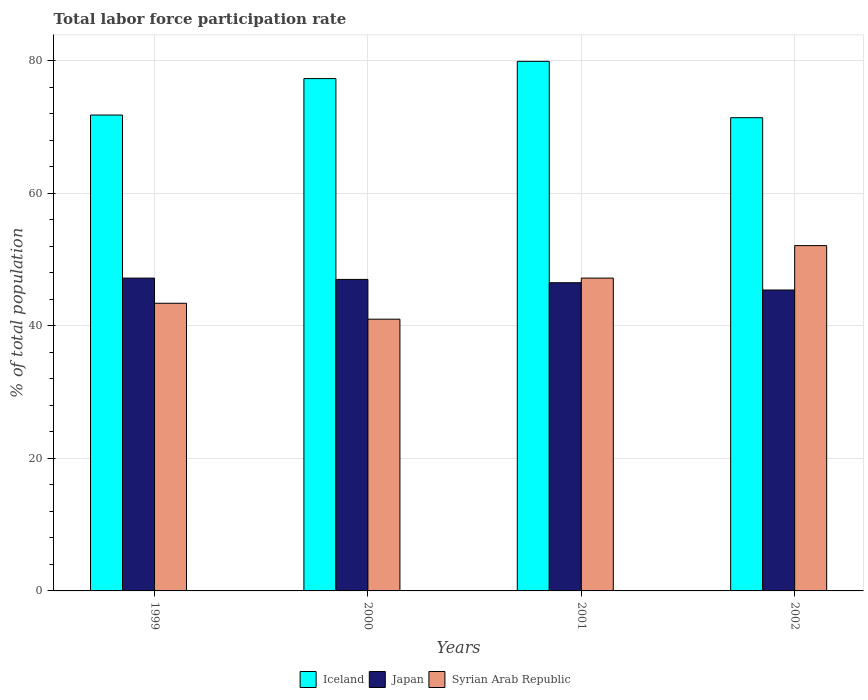Are the number of bars per tick equal to the number of legend labels?
Give a very brief answer. Yes. Are the number of bars on each tick of the X-axis equal?
Your answer should be very brief. Yes. How many bars are there on the 2nd tick from the right?
Provide a short and direct response. 3. What is the label of the 2nd group of bars from the left?
Keep it short and to the point. 2000. In how many cases, is the number of bars for a given year not equal to the number of legend labels?
Give a very brief answer. 0. What is the total labor force participation rate in Iceland in 2001?
Offer a very short reply. 79.9. Across all years, what is the maximum total labor force participation rate in Iceland?
Provide a short and direct response. 79.9. Across all years, what is the minimum total labor force participation rate in Japan?
Your answer should be compact. 45.4. In which year was the total labor force participation rate in Syrian Arab Republic maximum?
Your answer should be very brief. 2002. What is the total total labor force participation rate in Syrian Arab Republic in the graph?
Ensure brevity in your answer.  183.7. What is the difference between the total labor force participation rate in Iceland in 2000 and that in 2002?
Provide a short and direct response. 5.9. What is the difference between the total labor force participation rate in Japan in 2000 and the total labor force participation rate in Syrian Arab Republic in 1999?
Give a very brief answer. 3.6. What is the average total labor force participation rate in Iceland per year?
Keep it short and to the point. 75.1. In the year 2002, what is the difference between the total labor force participation rate in Syrian Arab Republic and total labor force participation rate in Iceland?
Your response must be concise. -19.3. What is the ratio of the total labor force participation rate in Iceland in 1999 to that in 2000?
Your response must be concise. 0.93. Is the total labor force participation rate in Japan in 1999 less than that in 2002?
Ensure brevity in your answer.  No. Is the difference between the total labor force participation rate in Syrian Arab Republic in 2001 and 2002 greater than the difference between the total labor force participation rate in Iceland in 2001 and 2002?
Give a very brief answer. No. What is the difference between the highest and the second highest total labor force participation rate in Iceland?
Your response must be concise. 2.6. What is the difference between the highest and the lowest total labor force participation rate in Iceland?
Offer a terse response. 8.5. In how many years, is the total labor force participation rate in Syrian Arab Republic greater than the average total labor force participation rate in Syrian Arab Republic taken over all years?
Provide a succinct answer. 2. Is the sum of the total labor force participation rate in Iceland in 1999 and 2001 greater than the maximum total labor force participation rate in Japan across all years?
Your answer should be compact. Yes. What does the 3rd bar from the left in 2002 represents?
Ensure brevity in your answer.  Syrian Arab Republic. Is it the case that in every year, the sum of the total labor force participation rate in Syrian Arab Republic and total labor force participation rate in Iceland is greater than the total labor force participation rate in Japan?
Provide a short and direct response. Yes. How many years are there in the graph?
Offer a very short reply. 4. What is the difference between two consecutive major ticks on the Y-axis?
Offer a terse response. 20. Does the graph contain grids?
Offer a very short reply. Yes. Where does the legend appear in the graph?
Provide a succinct answer. Bottom center. What is the title of the graph?
Ensure brevity in your answer.  Total labor force participation rate. What is the label or title of the X-axis?
Your answer should be very brief. Years. What is the label or title of the Y-axis?
Your answer should be compact. % of total population. What is the % of total population in Iceland in 1999?
Give a very brief answer. 71.8. What is the % of total population of Japan in 1999?
Your answer should be compact. 47.2. What is the % of total population of Syrian Arab Republic in 1999?
Your answer should be very brief. 43.4. What is the % of total population in Iceland in 2000?
Provide a short and direct response. 77.3. What is the % of total population of Iceland in 2001?
Provide a succinct answer. 79.9. What is the % of total population in Japan in 2001?
Provide a succinct answer. 46.5. What is the % of total population in Syrian Arab Republic in 2001?
Your answer should be compact. 47.2. What is the % of total population of Iceland in 2002?
Offer a terse response. 71.4. What is the % of total population in Japan in 2002?
Provide a short and direct response. 45.4. What is the % of total population of Syrian Arab Republic in 2002?
Keep it short and to the point. 52.1. Across all years, what is the maximum % of total population in Iceland?
Offer a terse response. 79.9. Across all years, what is the maximum % of total population of Japan?
Keep it short and to the point. 47.2. Across all years, what is the maximum % of total population in Syrian Arab Republic?
Provide a succinct answer. 52.1. Across all years, what is the minimum % of total population of Iceland?
Make the answer very short. 71.4. Across all years, what is the minimum % of total population in Japan?
Offer a terse response. 45.4. Across all years, what is the minimum % of total population in Syrian Arab Republic?
Give a very brief answer. 41. What is the total % of total population in Iceland in the graph?
Your answer should be very brief. 300.4. What is the total % of total population in Japan in the graph?
Give a very brief answer. 186.1. What is the total % of total population of Syrian Arab Republic in the graph?
Make the answer very short. 183.7. What is the difference between the % of total population of Syrian Arab Republic in 1999 and that in 2000?
Offer a very short reply. 2.4. What is the difference between the % of total population of Iceland in 1999 and that in 2002?
Offer a very short reply. 0.4. What is the difference between the % of total population in Japan in 1999 and that in 2002?
Keep it short and to the point. 1.8. What is the difference between the % of total population in Iceland in 2000 and that in 2001?
Offer a very short reply. -2.6. What is the difference between the % of total population of Japan in 2000 and that in 2001?
Provide a short and direct response. 0.5. What is the difference between the % of total population of Syrian Arab Republic in 2000 and that in 2001?
Provide a succinct answer. -6.2. What is the difference between the % of total population in Iceland in 1999 and the % of total population in Japan in 2000?
Your answer should be very brief. 24.8. What is the difference between the % of total population of Iceland in 1999 and the % of total population of Syrian Arab Republic in 2000?
Make the answer very short. 30.8. What is the difference between the % of total population of Iceland in 1999 and the % of total population of Japan in 2001?
Your answer should be compact. 25.3. What is the difference between the % of total population in Iceland in 1999 and the % of total population in Syrian Arab Republic in 2001?
Make the answer very short. 24.6. What is the difference between the % of total population of Japan in 1999 and the % of total population of Syrian Arab Republic in 2001?
Provide a short and direct response. 0. What is the difference between the % of total population of Iceland in 1999 and the % of total population of Japan in 2002?
Provide a short and direct response. 26.4. What is the difference between the % of total population in Iceland in 1999 and the % of total population in Syrian Arab Republic in 2002?
Provide a succinct answer. 19.7. What is the difference between the % of total population in Japan in 1999 and the % of total population in Syrian Arab Republic in 2002?
Provide a short and direct response. -4.9. What is the difference between the % of total population in Iceland in 2000 and the % of total population in Japan in 2001?
Your answer should be very brief. 30.8. What is the difference between the % of total population in Iceland in 2000 and the % of total population in Syrian Arab Republic in 2001?
Ensure brevity in your answer.  30.1. What is the difference between the % of total population of Japan in 2000 and the % of total population of Syrian Arab Republic in 2001?
Offer a very short reply. -0.2. What is the difference between the % of total population in Iceland in 2000 and the % of total population in Japan in 2002?
Make the answer very short. 31.9. What is the difference between the % of total population of Iceland in 2000 and the % of total population of Syrian Arab Republic in 2002?
Provide a short and direct response. 25.2. What is the difference between the % of total population in Japan in 2000 and the % of total population in Syrian Arab Republic in 2002?
Give a very brief answer. -5.1. What is the difference between the % of total population in Iceland in 2001 and the % of total population in Japan in 2002?
Offer a terse response. 34.5. What is the difference between the % of total population in Iceland in 2001 and the % of total population in Syrian Arab Republic in 2002?
Your answer should be very brief. 27.8. What is the average % of total population of Iceland per year?
Provide a short and direct response. 75.1. What is the average % of total population in Japan per year?
Make the answer very short. 46.52. What is the average % of total population of Syrian Arab Republic per year?
Provide a short and direct response. 45.92. In the year 1999, what is the difference between the % of total population of Iceland and % of total population of Japan?
Your answer should be very brief. 24.6. In the year 1999, what is the difference between the % of total population in Iceland and % of total population in Syrian Arab Republic?
Your answer should be compact. 28.4. In the year 1999, what is the difference between the % of total population in Japan and % of total population in Syrian Arab Republic?
Your response must be concise. 3.8. In the year 2000, what is the difference between the % of total population of Iceland and % of total population of Japan?
Your answer should be compact. 30.3. In the year 2000, what is the difference between the % of total population of Iceland and % of total population of Syrian Arab Republic?
Your answer should be very brief. 36.3. In the year 2001, what is the difference between the % of total population in Iceland and % of total population in Japan?
Offer a terse response. 33.4. In the year 2001, what is the difference between the % of total population of Iceland and % of total population of Syrian Arab Republic?
Offer a terse response. 32.7. In the year 2001, what is the difference between the % of total population in Japan and % of total population in Syrian Arab Republic?
Your answer should be compact. -0.7. In the year 2002, what is the difference between the % of total population of Iceland and % of total population of Japan?
Provide a short and direct response. 26. In the year 2002, what is the difference between the % of total population of Iceland and % of total population of Syrian Arab Republic?
Give a very brief answer. 19.3. What is the ratio of the % of total population in Iceland in 1999 to that in 2000?
Provide a short and direct response. 0.93. What is the ratio of the % of total population in Japan in 1999 to that in 2000?
Your response must be concise. 1. What is the ratio of the % of total population in Syrian Arab Republic in 1999 to that in 2000?
Your response must be concise. 1.06. What is the ratio of the % of total population of Iceland in 1999 to that in 2001?
Provide a short and direct response. 0.9. What is the ratio of the % of total population in Japan in 1999 to that in 2001?
Offer a terse response. 1.02. What is the ratio of the % of total population of Syrian Arab Republic in 1999 to that in 2001?
Your answer should be very brief. 0.92. What is the ratio of the % of total population of Iceland in 1999 to that in 2002?
Offer a very short reply. 1.01. What is the ratio of the % of total population of Japan in 1999 to that in 2002?
Provide a succinct answer. 1.04. What is the ratio of the % of total population in Syrian Arab Republic in 1999 to that in 2002?
Your response must be concise. 0.83. What is the ratio of the % of total population in Iceland in 2000 to that in 2001?
Your response must be concise. 0.97. What is the ratio of the % of total population of Japan in 2000 to that in 2001?
Provide a short and direct response. 1.01. What is the ratio of the % of total population of Syrian Arab Republic in 2000 to that in 2001?
Your answer should be very brief. 0.87. What is the ratio of the % of total population of Iceland in 2000 to that in 2002?
Your response must be concise. 1.08. What is the ratio of the % of total population of Japan in 2000 to that in 2002?
Your answer should be compact. 1.04. What is the ratio of the % of total population in Syrian Arab Republic in 2000 to that in 2002?
Provide a succinct answer. 0.79. What is the ratio of the % of total population in Iceland in 2001 to that in 2002?
Give a very brief answer. 1.12. What is the ratio of the % of total population in Japan in 2001 to that in 2002?
Give a very brief answer. 1.02. What is the ratio of the % of total population of Syrian Arab Republic in 2001 to that in 2002?
Make the answer very short. 0.91. What is the difference between the highest and the second highest % of total population of Syrian Arab Republic?
Give a very brief answer. 4.9. What is the difference between the highest and the lowest % of total population in Iceland?
Make the answer very short. 8.5. 